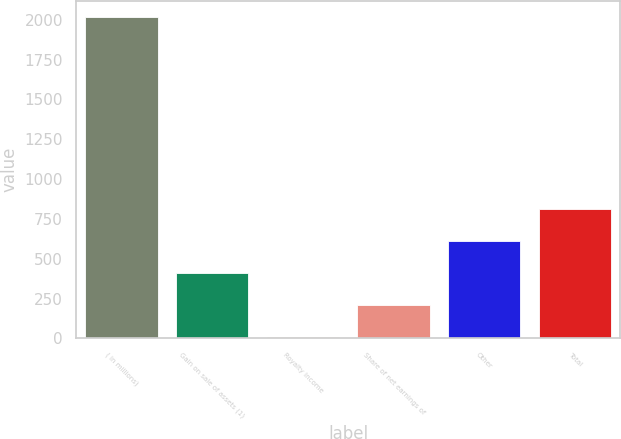Convert chart to OTSL. <chart><loc_0><loc_0><loc_500><loc_500><bar_chart><fcel>( in millions)<fcel>Gain on sale of assets (1)<fcel>Royalty income<fcel>Share of net earnings of<fcel>Other<fcel>Total<nl><fcel>2018<fcel>411.6<fcel>10<fcel>210.8<fcel>612.4<fcel>813.2<nl></chart> 